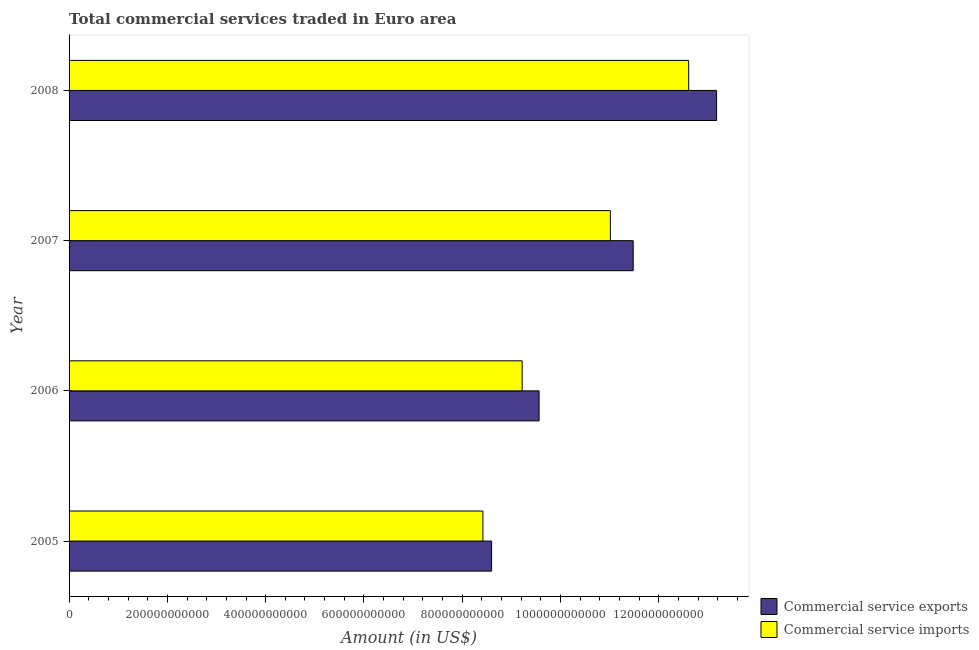How many groups of bars are there?
Your answer should be compact. 4. Are the number of bars on each tick of the Y-axis equal?
Ensure brevity in your answer.  Yes. How many bars are there on the 1st tick from the bottom?
Provide a succinct answer. 2. What is the label of the 1st group of bars from the top?
Your answer should be very brief. 2008. In how many cases, is the number of bars for a given year not equal to the number of legend labels?
Give a very brief answer. 0. What is the amount of commercial service exports in 2007?
Ensure brevity in your answer.  1.15e+12. Across all years, what is the maximum amount of commercial service imports?
Your answer should be compact. 1.26e+12. Across all years, what is the minimum amount of commercial service imports?
Offer a very short reply. 8.42e+11. In which year was the amount of commercial service exports minimum?
Offer a terse response. 2005. What is the total amount of commercial service imports in the graph?
Your response must be concise. 4.13e+12. What is the difference between the amount of commercial service imports in 2006 and that in 2008?
Ensure brevity in your answer.  -3.39e+11. What is the difference between the amount of commercial service exports in 2006 and the amount of commercial service imports in 2005?
Your response must be concise. 1.14e+11. What is the average amount of commercial service exports per year?
Provide a succinct answer. 1.07e+12. In the year 2005, what is the difference between the amount of commercial service exports and amount of commercial service imports?
Provide a succinct answer. 1.77e+1. What is the ratio of the amount of commercial service imports in 2007 to that in 2008?
Offer a very short reply. 0.87. What is the difference between the highest and the second highest amount of commercial service imports?
Provide a succinct answer. 1.59e+11. What is the difference between the highest and the lowest amount of commercial service imports?
Your response must be concise. 4.19e+11. In how many years, is the amount of commercial service imports greater than the average amount of commercial service imports taken over all years?
Offer a terse response. 2. What does the 2nd bar from the top in 2007 represents?
Ensure brevity in your answer.  Commercial service exports. What does the 2nd bar from the bottom in 2005 represents?
Offer a very short reply. Commercial service imports. Are all the bars in the graph horizontal?
Your answer should be compact. Yes. What is the difference between two consecutive major ticks on the X-axis?
Your answer should be compact. 2.00e+11. Are the values on the major ticks of X-axis written in scientific E-notation?
Provide a succinct answer. No. Does the graph contain any zero values?
Your response must be concise. No. How many legend labels are there?
Provide a short and direct response. 2. What is the title of the graph?
Make the answer very short. Total commercial services traded in Euro area. What is the label or title of the X-axis?
Give a very brief answer. Amount (in US$). What is the label or title of the Y-axis?
Your response must be concise. Year. What is the Amount (in US$) of Commercial service exports in 2005?
Your answer should be very brief. 8.60e+11. What is the Amount (in US$) in Commercial service imports in 2005?
Offer a very short reply. 8.42e+11. What is the Amount (in US$) in Commercial service exports in 2006?
Your response must be concise. 9.56e+11. What is the Amount (in US$) of Commercial service imports in 2006?
Keep it short and to the point. 9.22e+11. What is the Amount (in US$) in Commercial service exports in 2007?
Offer a very short reply. 1.15e+12. What is the Amount (in US$) in Commercial service imports in 2007?
Offer a terse response. 1.10e+12. What is the Amount (in US$) in Commercial service exports in 2008?
Ensure brevity in your answer.  1.32e+12. What is the Amount (in US$) in Commercial service imports in 2008?
Your answer should be very brief. 1.26e+12. Across all years, what is the maximum Amount (in US$) in Commercial service exports?
Your response must be concise. 1.32e+12. Across all years, what is the maximum Amount (in US$) in Commercial service imports?
Offer a very short reply. 1.26e+12. Across all years, what is the minimum Amount (in US$) of Commercial service exports?
Make the answer very short. 8.60e+11. Across all years, what is the minimum Amount (in US$) in Commercial service imports?
Give a very brief answer. 8.42e+11. What is the total Amount (in US$) in Commercial service exports in the graph?
Give a very brief answer. 4.28e+12. What is the total Amount (in US$) in Commercial service imports in the graph?
Offer a terse response. 4.13e+12. What is the difference between the Amount (in US$) of Commercial service exports in 2005 and that in 2006?
Your answer should be very brief. -9.67e+1. What is the difference between the Amount (in US$) in Commercial service imports in 2005 and that in 2006?
Keep it short and to the point. -7.99e+1. What is the difference between the Amount (in US$) of Commercial service exports in 2005 and that in 2007?
Give a very brief answer. -2.88e+11. What is the difference between the Amount (in US$) of Commercial service imports in 2005 and that in 2007?
Keep it short and to the point. -2.59e+11. What is the difference between the Amount (in US$) in Commercial service exports in 2005 and that in 2008?
Make the answer very short. -4.58e+11. What is the difference between the Amount (in US$) of Commercial service imports in 2005 and that in 2008?
Make the answer very short. -4.19e+11. What is the difference between the Amount (in US$) in Commercial service exports in 2006 and that in 2007?
Provide a short and direct response. -1.91e+11. What is the difference between the Amount (in US$) in Commercial service imports in 2006 and that in 2007?
Your answer should be very brief. -1.80e+11. What is the difference between the Amount (in US$) of Commercial service exports in 2006 and that in 2008?
Your answer should be very brief. -3.61e+11. What is the difference between the Amount (in US$) of Commercial service imports in 2006 and that in 2008?
Your answer should be very brief. -3.39e+11. What is the difference between the Amount (in US$) of Commercial service exports in 2007 and that in 2008?
Keep it short and to the point. -1.70e+11. What is the difference between the Amount (in US$) in Commercial service imports in 2007 and that in 2008?
Give a very brief answer. -1.59e+11. What is the difference between the Amount (in US$) of Commercial service exports in 2005 and the Amount (in US$) of Commercial service imports in 2006?
Offer a terse response. -6.22e+1. What is the difference between the Amount (in US$) of Commercial service exports in 2005 and the Amount (in US$) of Commercial service imports in 2007?
Offer a very short reply. -2.42e+11. What is the difference between the Amount (in US$) of Commercial service exports in 2005 and the Amount (in US$) of Commercial service imports in 2008?
Make the answer very short. -4.01e+11. What is the difference between the Amount (in US$) of Commercial service exports in 2006 and the Amount (in US$) of Commercial service imports in 2007?
Your answer should be very brief. -1.45e+11. What is the difference between the Amount (in US$) in Commercial service exports in 2006 and the Amount (in US$) in Commercial service imports in 2008?
Provide a short and direct response. -3.04e+11. What is the difference between the Amount (in US$) in Commercial service exports in 2007 and the Amount (in US$) in Commercial service imports in 2008?
Your answer should be very brief. -1.13e+11. What is the average Amount (in US$) in Commercial service exports per year?
Provide a short and direct response. 1.07e+12. What is the average Amount (in US$) of Commercial service imports per year?
Your response must be concise. 1.03e+12. In the year 2005, what is the difference between the Amount (in US$) in Commercial service exports and Amount (in US$) in Commercial service imports?
Make the answer very short. 1.77e+1. In the year 2006, what is the difference between the Amount (in US$) in Commercial service exports and Amount (in US$) in Commercial service imports?
Your answer should be compact. 3.44e+1. In the year 2007, what is the difference between the Amount (in US$) of Commercial service exports and Amount (in US$) of Commercial service imports?
Your response must be concise. 4.64e+1. In the year 2008, what is the difference between the Amount (in US$) in Commercial service exports and Amount (in US$) in Commercial service imports?
Your response must be concise. 5.69e+1. What is the ratio of the Amount (in US$) in Commercial service exports in 2005 to that in 2006?
Your response must be concise. 0.9. What is the ratio of the Amount (in US$) of Commercial service imports in 2005 to that in 2006?
Keep it short and to the point. 0.91. What is the ratio of the Amount (in US$) in Commercial service exports in 2005 to that in 2007?
Provide a succinct answer. 0.75. What is the ratio of the Amount (in US$) in Commercial service imports in 2005 to that in 2007?
Offer a terse response. 0.76. What is the ratio of the Amount (in US$) in Commercial service exports in 2005 to that in 2008?
Keep it short and to the point. 0.65. What is the ratio of the Amount (in US$) of Commercial service imports in 2005 to that in 2008?
Provide a short and direct response. 0.67. What is the ratio of the Amount (in US$) of Commercial service exports in 2006 to that in 2007?
Give a very brief answer. 0.83. What is the ratio of the Amount (in US$) in Commercial service imports in 2006 to that in 2007?
Provide a short and direct response. 0.84. What is the ratio of the Amount (in US$) in Commercial service exports in 2006 to that in 2008?
Your answer should be very brief. 0.73. What is the ratio of the Amount (in US$) of Commercial service imports in 2006 to that in 2008?
Provide a succinct answer. 0.73. What is the ratio of the Amount (in US$) in Commercial service exports in 2007 to that in 2008?
Provide a short and direct response. 0.87. What is the ratio of the Amount (in US$) of Commercial service imports in 2007 to that in 2008?
Keep it short and to the point. 0.87. What is the difference between the highest and the second highest Amount (in US$) of Commercial service exports?
Your answer should be very brief. 1.70e+11. What is the difference between the highest and the second highest Amount (in US$) in Commercial service imports?
Ensure brevity in your answer.  1.59e+11. What is the difference between the highest and the lowest Amount (in US$) of Commercial service exports?
Provide a succinct answer. 4.58e+11. What is the difference between the highest and the lowest Amount (in US$) in Commercial service imports?
Provide a short and direct response. 4.19e+11. 